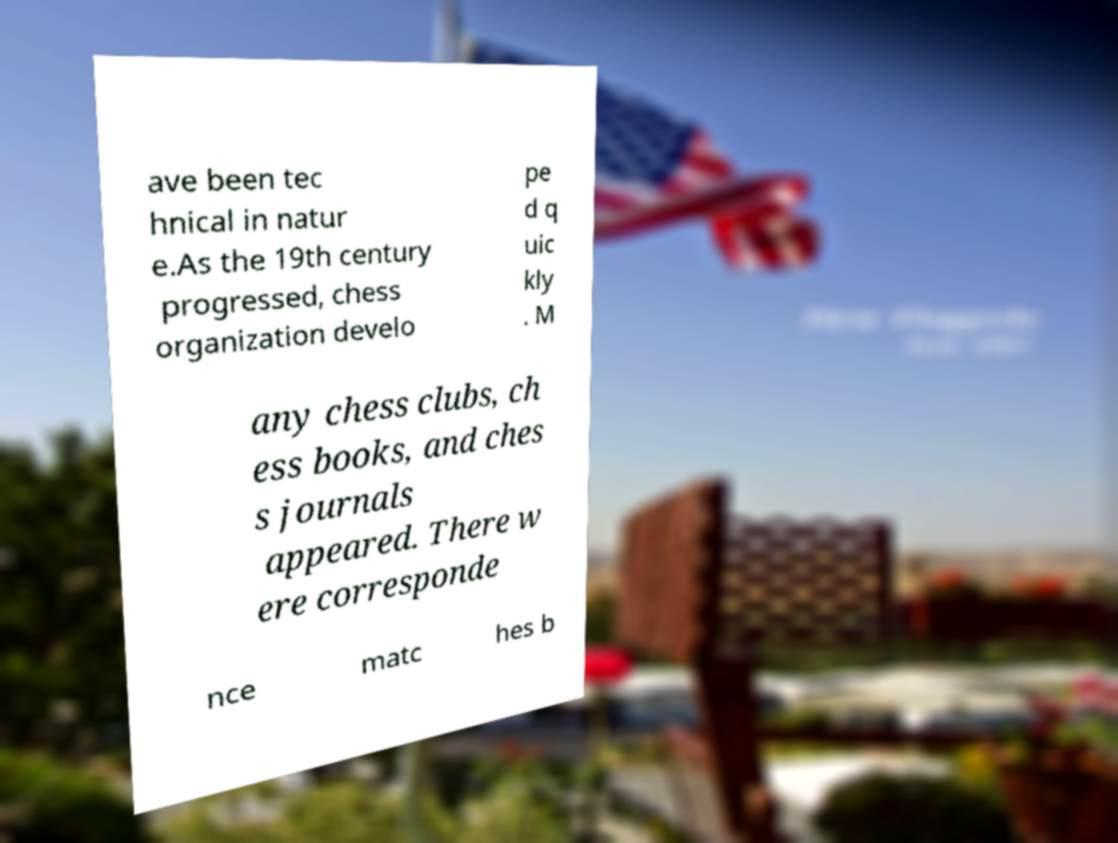Can you accurately transcribe the text from the provided image for me? ave been tec hnical in natur e.As the 19th century progressed, chess organization develo pe d q uic kly . M any chess clubs, ch ess books, and ches s journals appeared. There w ere corresponde nce matc hes b 